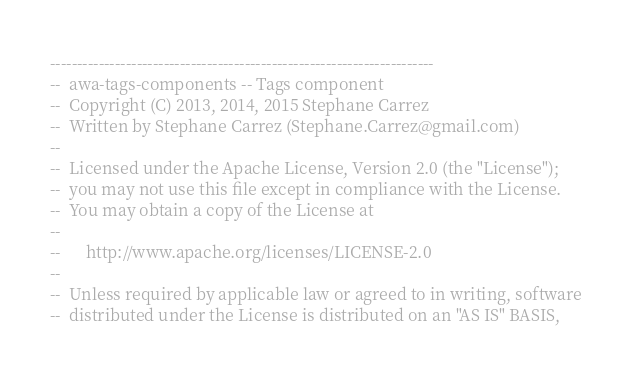Convert code to text. <code><loc_0><loc_0><loc_500><loc_500><_Ada_>-----------------------------------------------------------------------
--  awa-tags-components -- Tags component
--  Copyright (C) 2013, 2014, 2015 Stephane Carrez
--  Written by Stephane Carrez (Stephane.Carrez@gmail.com)
--
--  Licensed under the Apache License, Version 2.0 (the "License");
--  you may not use this file except in compliance with the License.
--  You may obtain a copy of the License at
--
--      http://www.apache.org/licenses/LICENSE-2.0
--
--  Unless required by applicable law or agreed to in writing, software
--  distributed under the License is distributed on an "AS IS" BASIS,</code> 